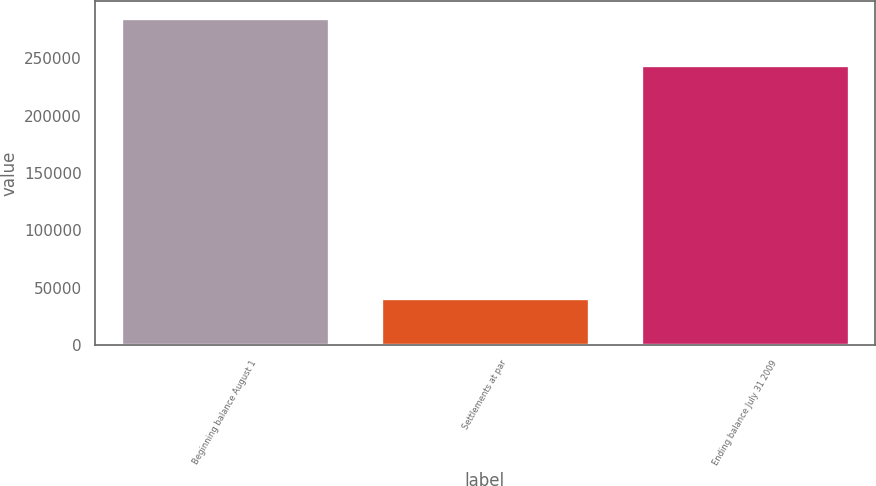Convert chart. <chart><loc_0><loc_0><loc_500><loc_500><bar_chart><fcel>Beginning balance August 1<fcel>Settlements at par<fcel>Ending balance July 31 2009<nl><fcel>285325<fcel>40800<fcel>244525<nl></chart> 